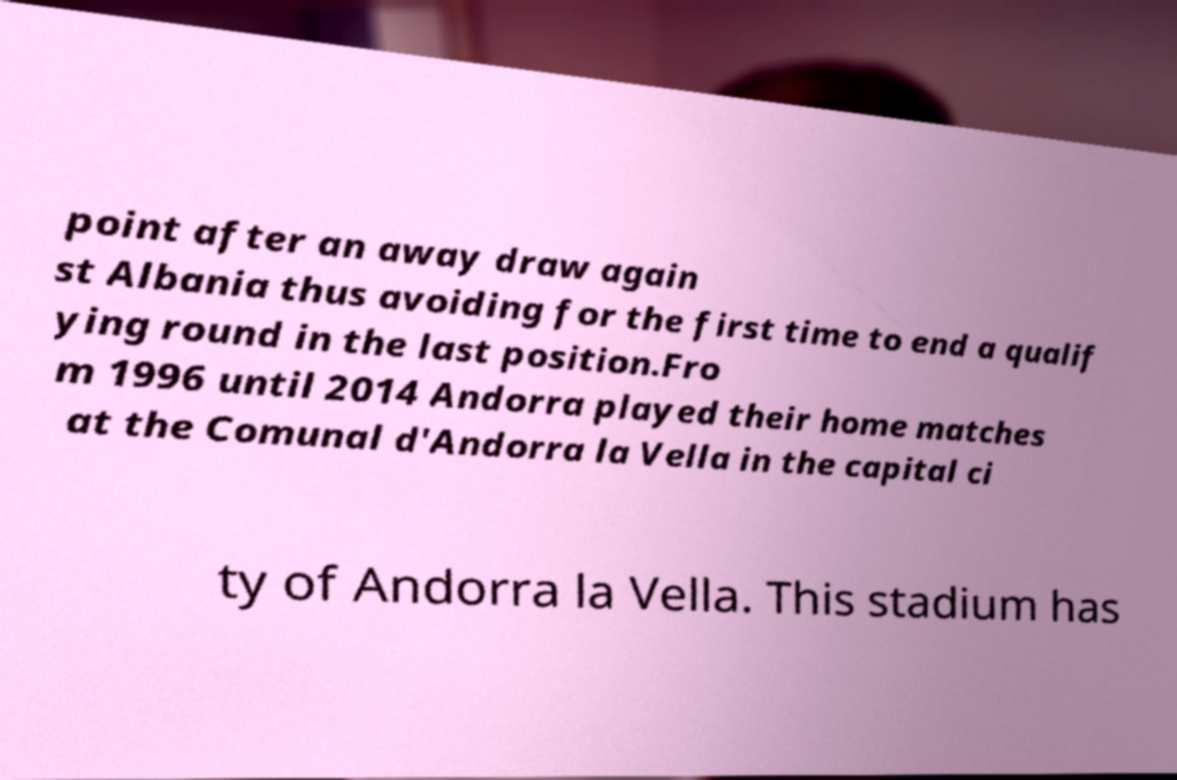Please identify and transcribe the text found in this image. point after an away draw again st Albania thus avoiding for the first time to end a qualif ying round in the last position.Fro m 1996 until 2014 Andorra played their home matches at the Comunal d'Andorra la Vella in the capital ci ty of Andorra la Vella. This stadium has 